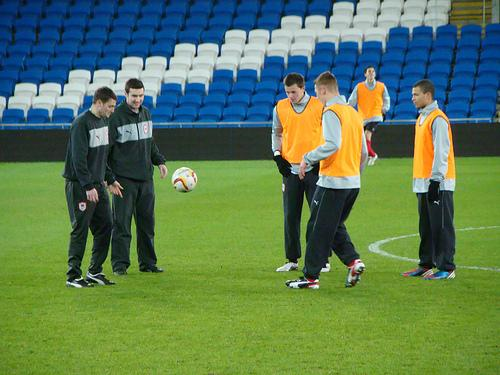How many black and white soccer cleats are visible in the image? There is one pair of black and white soccer cleats visible in the image. What are some players wearing on their hands? Some players are wearing black gloves. In terms of color, what are the most distinctive features seen on the soccer field? The most distinctive features on the soccer field are the yellow vests, green grass, and red and white soccer ball. How many players are wearing yellow vests in the image? Four players are wearing yellow vests. Are there any spectators in the image? If so, where are they located? There are no spectators in the image, just empty blue and white seats. Can you describe the scene where the image takes place? The image shows a soccer field with players in black and yellow vests, a red and white soccer ball, green grass, and empty blue and white seats in a stadium. What are the soccer players mainly doing in the image? The soccer players are mainly playing soccer and standing on the field. What are the colors of the soccer ball in the image? The soccer ball is red and white. What type of object is located at X:366 Y:225? White line on a green field Describe any empty seating arrangements in the image. Empty blue and white seats Describe the quality of the image, is it high or low resolution? High resolution Is there any anomaly detected in the image, such as misplaced or unrelated objects? No List three captions for the object at X:57 Y:82 in the image. 1. Man in black playing soccer 2. Player in grey outfit and black shoes 3. Two men standing beside each other Describe the gloves at the coordinates X:269 Y:146. Black gloves on man with yellow vest Identify the color of the vest on the man with coordinates X:317 Y:99. Yellow Name the object located at X:275 Y:65 with its main characteristics. Man has brown hair Which task consists of grounding referring expressions from natural language sentences to image regions? Referential Expression Grounding Task Identify the main sentiment of the image. Positive What type of interaction is happening between the soccer players in the image? They are playing soccer and competing for the ball. What is the main activity of the people in the image? Playing soccer For the object at X:339 Y:256, explain the main components of its appearance. Soccer cleat on man with yellow vest Which group of people are interacting on the soccer field? Soccer players Count the number of men in black playing soccer in the image. 2 What type of task requires identifying object attributes such as the color of the vest on the man with coordinates X:317 Y:99? Object Attribute Detection What type of question is "What is the main activity of the people in the image?"? Interrogative List three different captions for the object at X:57 Y:71. 1. Man in black playing soccer 2. Two men wearing black sweatshirts 3. Player in grey outfit and black shoes Is there an object in the image that is floating in the air? Yes, a red and white soccer ball 